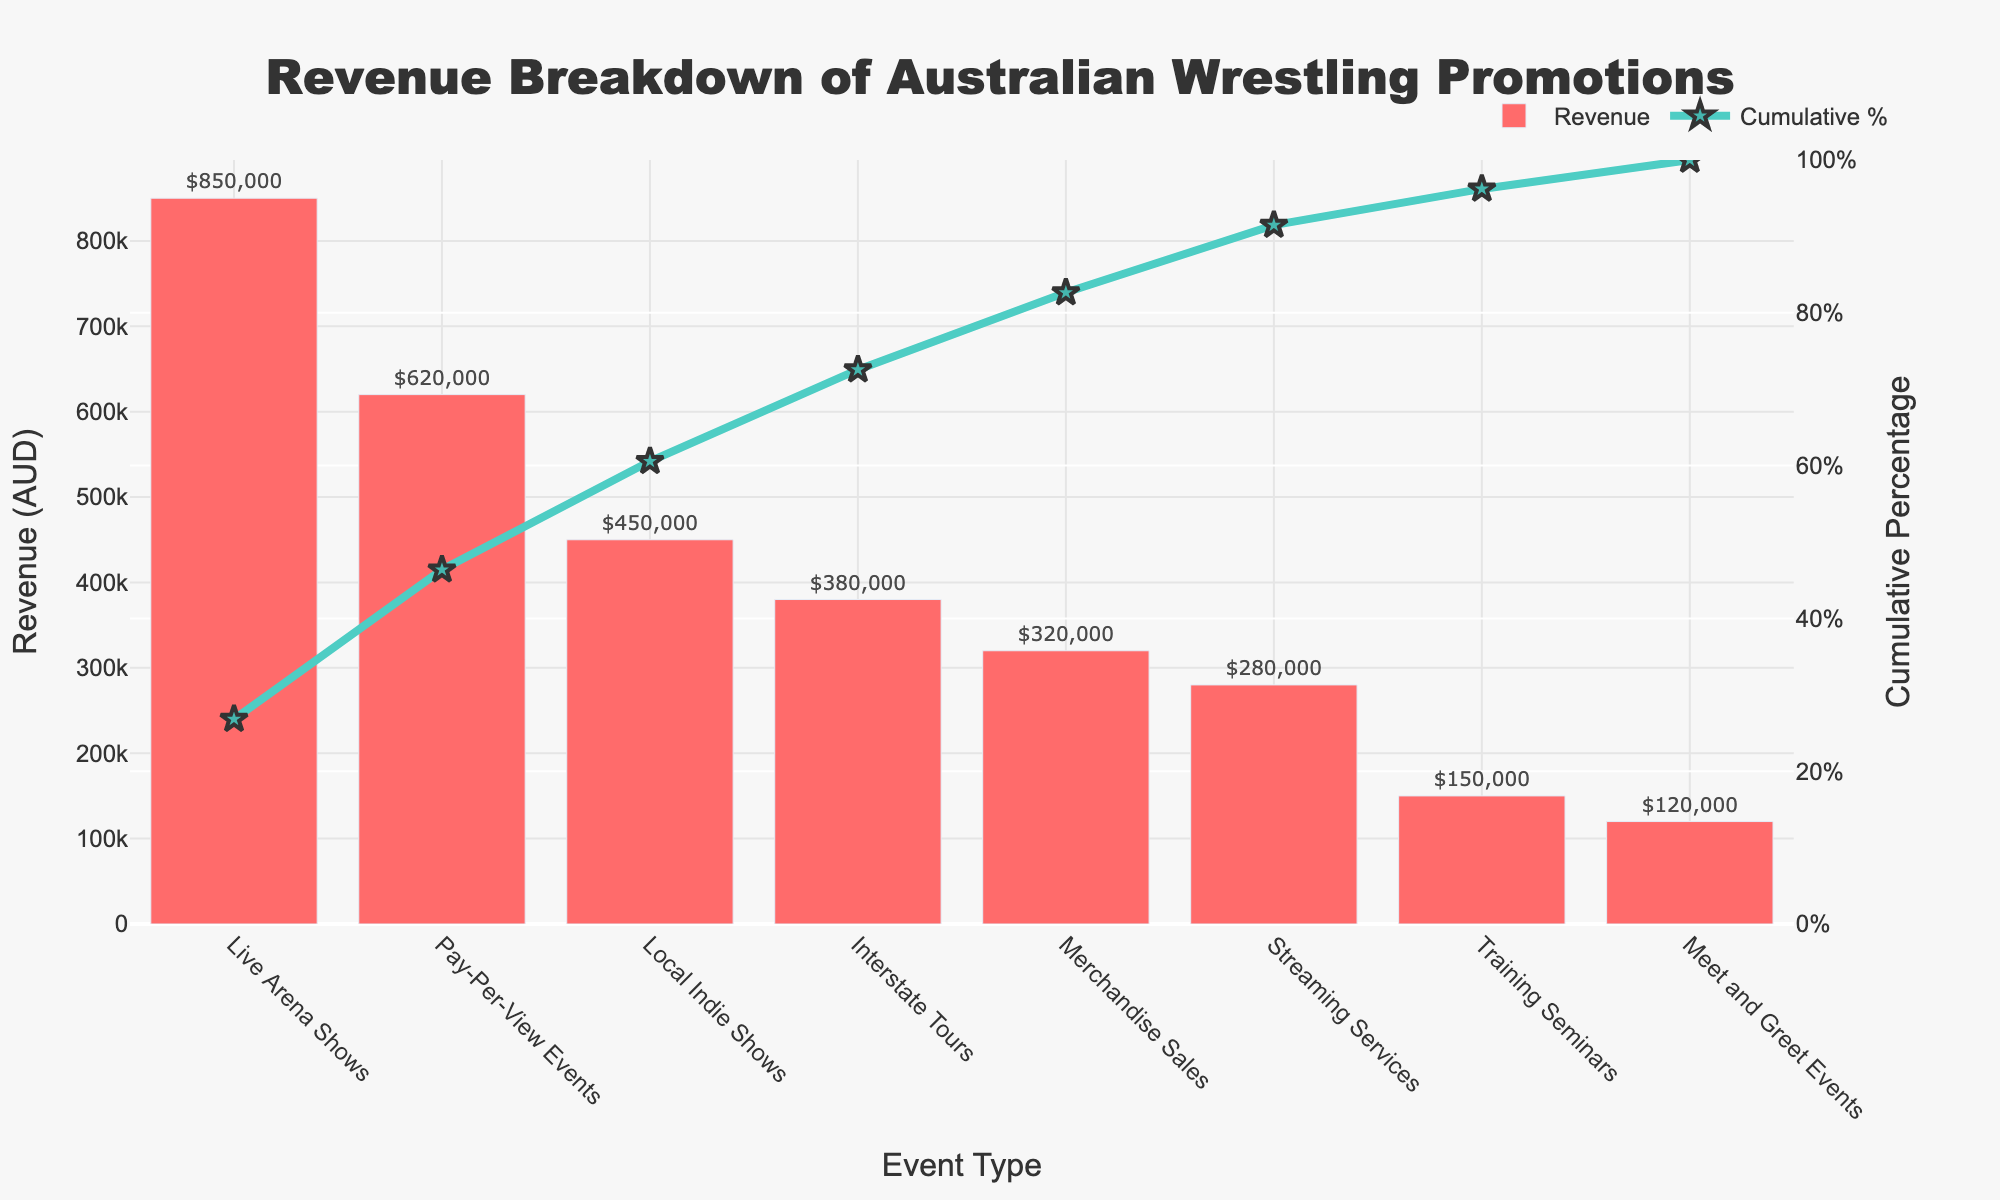What is the title of the chart? The title is the text at the top of the chart, which summarizes what the chart represents. The text "Revenue Breakdown of Australian Wrestling Promotions" is displayed as the title in the figure.
Answer: Revenue Breakdown of Australian Wrestling Promotions Which event type generates the highest revenue? By looking at the bars on the chart, we can identify the tallest bar to determine the event type with the highest revenue. The "Live Arena Shows" bar is the tallest.
Answer: Live Arena Shows What is the revenue value for Pay-Per-View Events? The revenue values are displayed at the top of each bar. For "Pay-Per-View Events," the value displayed at the top of the bar shows $620,000.
Answer: 620,000 AUD Which event types contribute to the first 50% of cumulative revenue? To find the event types contributing to the first 50%, we can look at the cumulative percentage line and identify the event types up to the point where it reaches 50%. "Live Arena Shows" and "Pay-Per-View Events" combined contribute to the first 50%.
Answer: Live Arena Shows and Pay-Per-View Events How many event types generate more than 300,000 AUD in revenue? We count the number of bars that are taller than the 300,000 AUD mark. The event types are "Live Arena Shows," "Pay-Per-View Events," "Local Indie Shows," and "Interstate Tours."
Answer: Four What is the cumulative percentage after including Merchandise Sales? To find the cumulative percentage after "Merchandise Sales," we trace the cumulative line up to this event type. It shows that the cumulative percentage is approximately 81.7%.
Answer: 81.7% Which event type generates the lowest revenue and how much? The shortest bar on the chart represents the event type with the lowest revenue. "Meet and Greet Events" has the shortest bar, and the text shows $120,000.
Answer: Meet and Greet Events, 120,000 AUD What is the total revenue from Live Arena Shows and Local Indie Shows combined? Sum the revenue values of both "Live Arena Shows" and "Local Indie Shows." The calculation is 850,000 + 450,000 = 1,300,000 AUD.
Answer: 1,300,000 AUD How does the revenue from Streaming Services compare to that of Merchandise Sales? To compare, look at the heights of the bars for both event types. "Streaming Services" generates less revenue than "Merchandise Sales." The revenue for "Streaming Services" is $280,000, while for "Merchandise Sales" it is $320,000.
Answer: Streaming Services generates less revenue than Merchandise Sales What is the range of revenue values shown in the chart? The range is calculated by subtracting the lowest revenue value from the highest revenue value. The highest is $850,000 (Live Arena Shows), and the lowest is $120,000 (Meet and Greet Events). So, 850,000 - 120,000 = 730,000 AUD.
Answer: 730,000 AUD 